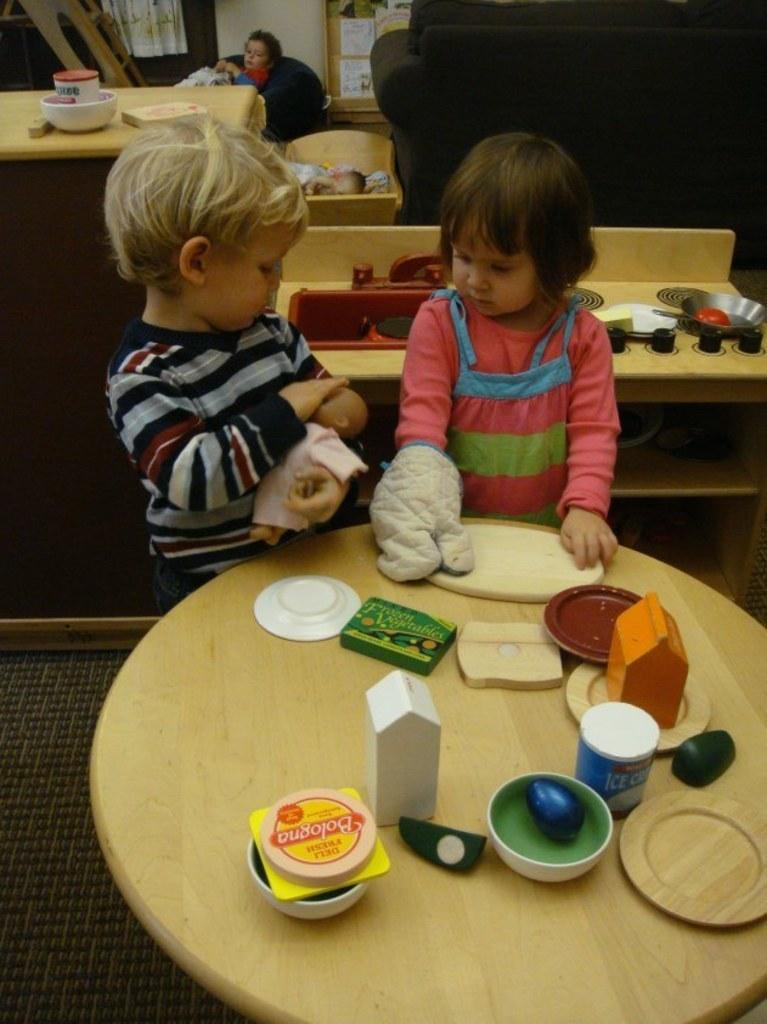What color is the table that is visible in the image? There is a yellow table in the image. What is on top of the yellow table? There are objects on the table. How many kids are standing in the image? There are two kids standing in the image. Can you describe the background of the image? There is another table in the background of the image. What type of rings are the kids wearing in the image? There is no mention of rings in the image, so we cannot determine if the kids are wearing any. 